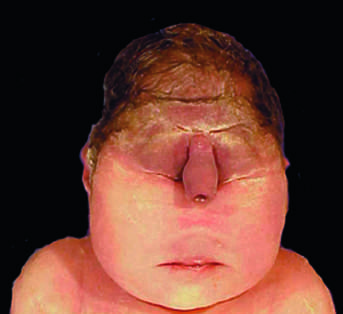s atrophy associated with severe internal anomalies such as maldevelopment of the brain and cardiac defects in almost all cases?
Answer the question using a single word or phrase. No 